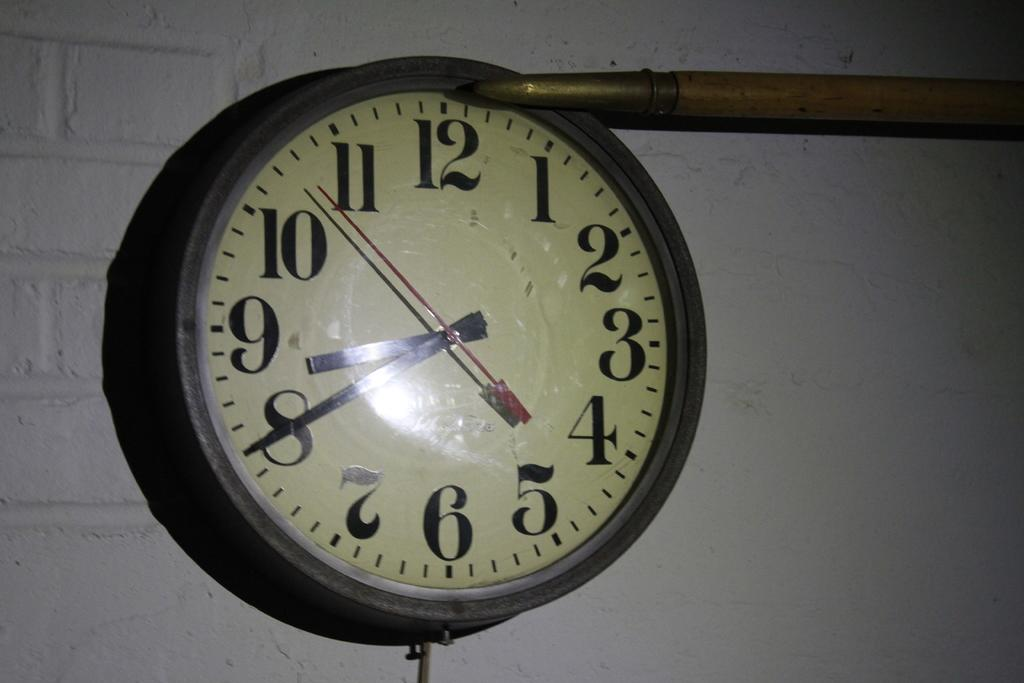Provide a one-sentence caption for the provided image. A large clock has hands displaying a time of eight forty. 